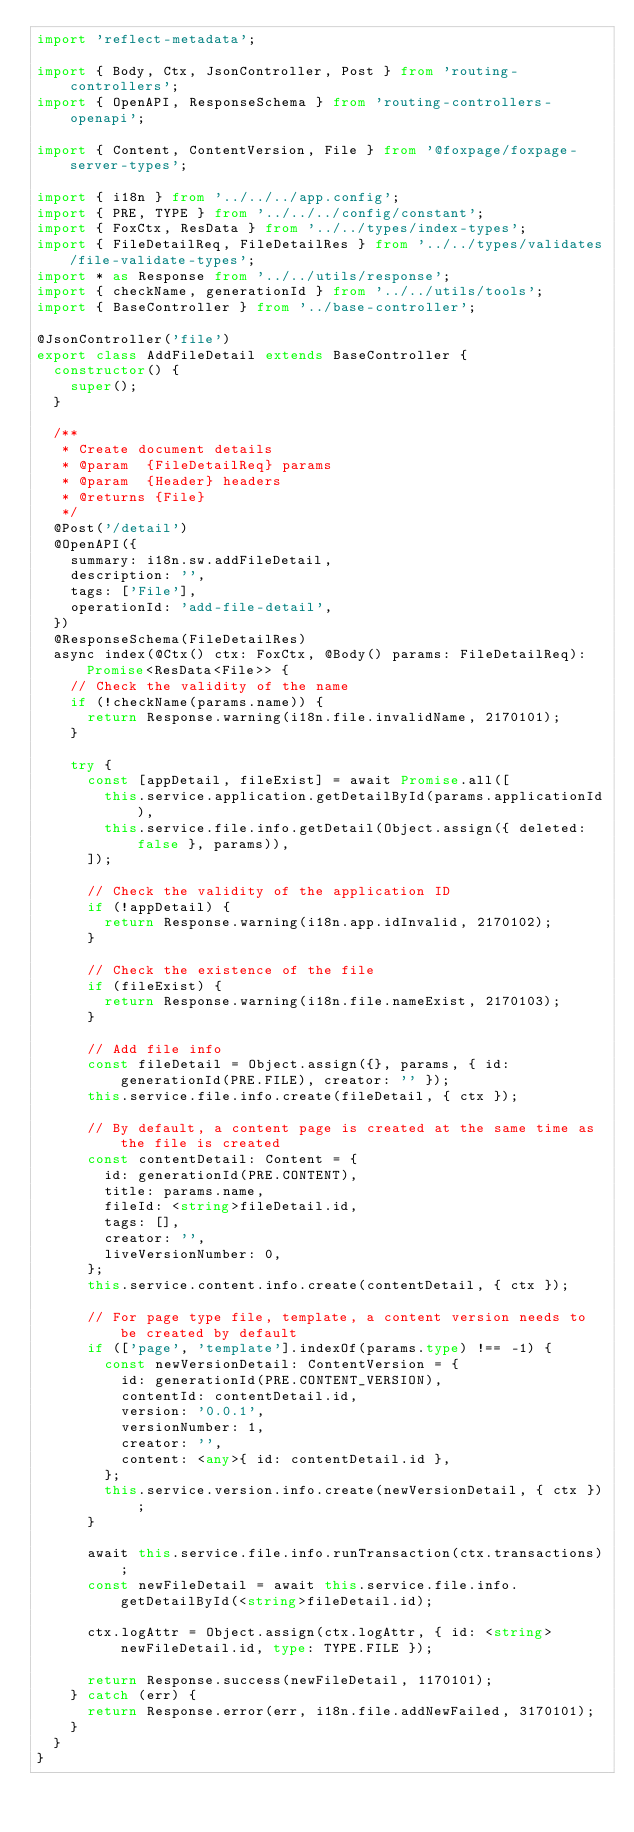Convert code to text. <code><loc_0><loc_0><loc_500><loc_500><_TypeScript_>import 'reflect-metadata';

import { Body, Ctx, JsonController, Post } from 'routing-controllers';
import { OpenAPI, ResponseSchema } from 'routing-controllers-openapi';

import { Content, ContentVersion, File } from '@foxpage/foxpage-server-types';

import { i18n } from '../../../app.config';
import { PRE, TYPE } from '../../../config/constant';
import { FoxCtx, ResData } from '../../types/index-types';
import { FileDetailReq, FileDetailRes } from '../../types/validates/file-validate-types';
import * as Response from '../../utils/response';
import { checkName, generationId } from '../../utils/tools';
import { BaseController } from '../base-controller';

@JsonController('file')
export class AddFileDetail extends BaseController {
  constructor() {
    super();
  }

  /**
   * Create document details
   * @param  {FileDetailReq} params
   * @param  {Header} headers
   * @returns {File}
   */
  @Post('/detail')
  @OpenAPI({
    summary: i18n.sw.addFileDetail,
    description: '',
    tags: ['File'],
    operationId: 'add-file-detail',
  })
  @ResponseSchema(FileDetailRes)
  async index(@Ctx() ctx: FoxCtx, @Body() params: FileDetailReq): Promise<ResData<File>> {
    // Check the validity of the name
    if (!checkName(params.name)) {
      return Response.warning(i18n.file.invalidName, 2170101);
    }

    try {
      const [appDetail, fileExist] = await Promise.all([
        this.service.application.getDetailById(params.applicationId),
        this.service.file.info.getDetail(Object.assign({ deleted: false }, params)),
      ]);

      // Check the validity of the application ID
      if (!appDetail) {
        return Response.warning(i18n.app.idInvalid, 2170102);
      }

      // Check the existence of the file
      if (fileExist) {
        return Response.warning(i18n.file.nameExist, 2170103);
      }

      // Add file info
      const fileDetail = Object.assign({}, params, { id: generationId(PRE.FILE), creator: '' });
      this.service.file.info.create(fileDetail, { ctx });

      // By default, a content page is created at the same time as the file is created
      const contentDetail: Content = {
        id: generationId(PRE.CONTENT),
        title: params.name,
        fileId: <string>fileDetail.id,
        tags: [],
        creator: '',
        liveVersionNumber: 0,
      };
      this.service.content.info.create(contentDetail, { ctx });

      // For page type file, template, a content version needs to be created by default
      if (['page', 'template'].indexOf(params.type) !== -1) {
        const newVersionDetail: ContentVersion = {
          id: generationId(PRE.CONTENT_VERSION),
          contentId: contentDetail.id,
          version: '0.0.1',
          versionNumber: 1,
          creator: '',
          content: <any>{ id: contentDetail.id },
        };
        this.service.version.info.create(newVersionDetail, { ctx });
      }

      await this.service.file.info.runTransaction(ctx.transactions);
      const newFileDetail = await this.service.file.info.getDetailById(<string>fileDetail.id);

      ctx.logAttr = Object.assign(ctx.logAttr, { id: <string>newFileDetail.id, type: TYPE.FILE });

      return Response.success(newFileDetail, 1170101);
    } catch (err) {
      return Response.error(err, i18n.file.addNewFailed, 3170101);
    }
  }
}
</code> 